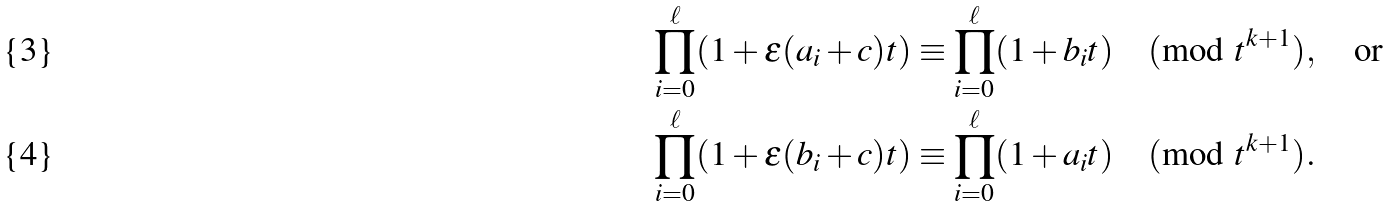<formula> <loc_0><loc_0><loc_500><loc_500>& \prod _ { i = 0 } ^ { \ell } ( 1 + \epsilon ( a _ { i } + c ) t ) \equiv \prod _ { i = 0 } ^ { \ell } ( 1 + b _ { i } t ) \pmod { t ^ { k + 1 } } , \quad \text {or} \\ & \prod _ { i = 0 } ^ { \ell } ( 1 + \epsilon ( b _ { i } + c ) t ) \equiv \prod _ { i = 0 } ^ { \ell } ( 1 + a _ { i } t ) \pmod { t ^ { k + 1 } } .</formula> 